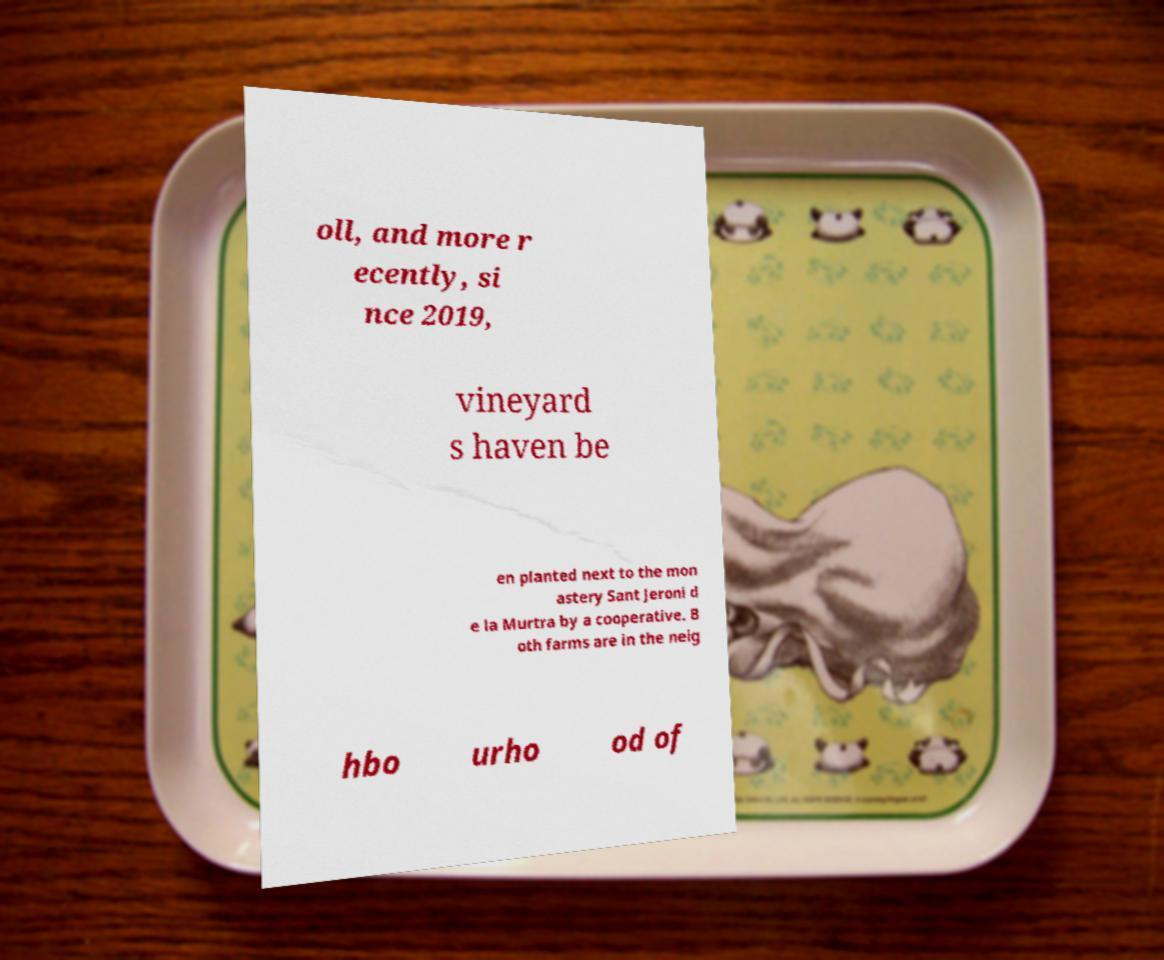For documentation purposes, I need the text within this image transcribed. Could you provide that? oll, and more r ecently, si nce 2019, vineyard s haven be en planted next to the mon astery Sant Jeroni d e la Murtra by a cooperative. B oth farms are in the neig hbo urho od of 